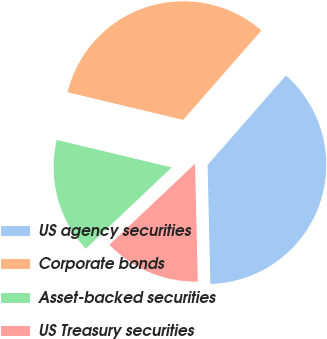<chart> <loc_0><loc_0><loc_500><loc_500><pie_chart><fcel>US agency securities<fcel>Corporate bonds<fcel>Asset-backed securities<fcel>US Treasury securities<nl><fcel>38.19%<fcel>32.7%<fcel>15.8%<fcel>13.31%<nl></chart> 